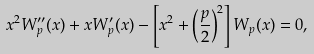Convert formula to latex. <formula><loc_0><loc_0><loc_500><loc_500>x ^ { 2 } W ^ { \prime \prime } _ { p } ( x ) + x W ^ { \prime } _ { p } ( x ) - \left [ x ^ { 2 } + \left ( \frac { p } { 2 } \right ) ^ { 2 } \right ] W _ { p } ( x ) = 0 ,</formula> 